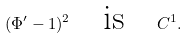Convert formula to latex. <formula><loc_0><loc_0><loc_500><loc_500>\label l { e q \colon P h i } ( \Phi ^ { \prime } - 1 ) ^ { 2 } \quad \text {is} \quad C ^ { 1 } .</formula> 